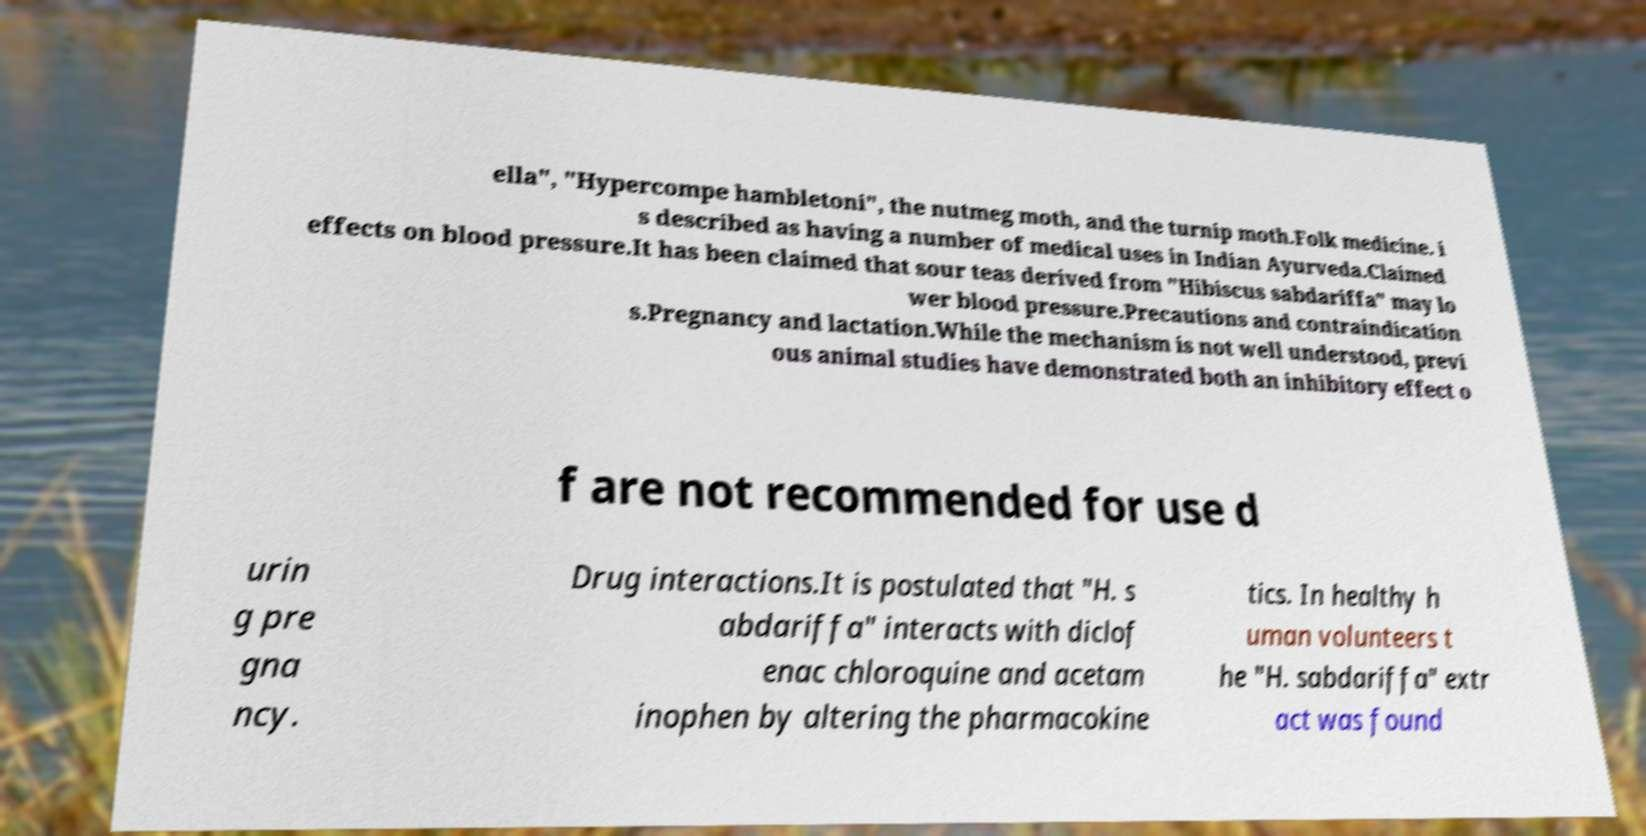Please identify and transcribe the text found in this image. ella", "Hypercompe hambletoni", the nutmeg moth, and the turnip moth.Folk medicine. i s described as having a number of medical uses in Indian Ayurveda.Claimed effects on blood pressure.It has been claimed that sour teas derived from "Hibiscus sabdariffa" may lo wer blood pressure.Precautions and contraindication s.Pregnancy and lactation.While the mechanism is not well understood, previ ous animal studies have demonstrated both an inhibitory effect o f are not recommended for use d urin g pre gna ncy. Drug interactions.It is postulated that "H. s abdariffa" interacts with diclof enac chloroquine and acetam inophen by altering the pharmacokine tics. In healthy h uman volunteers t he "H. sabdariffa" extr act was found 